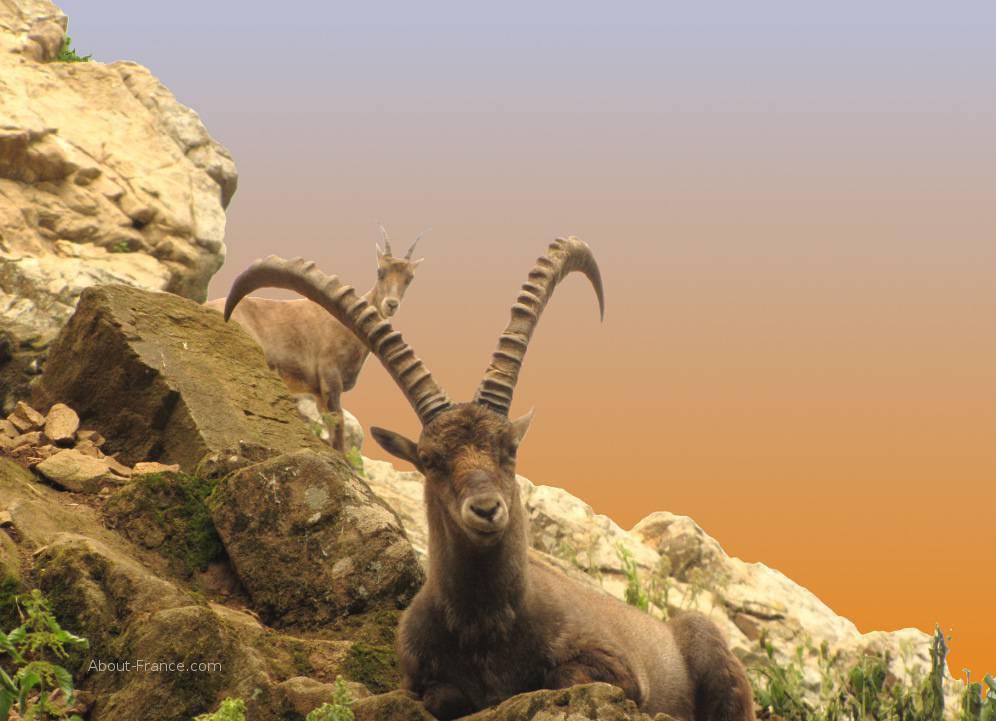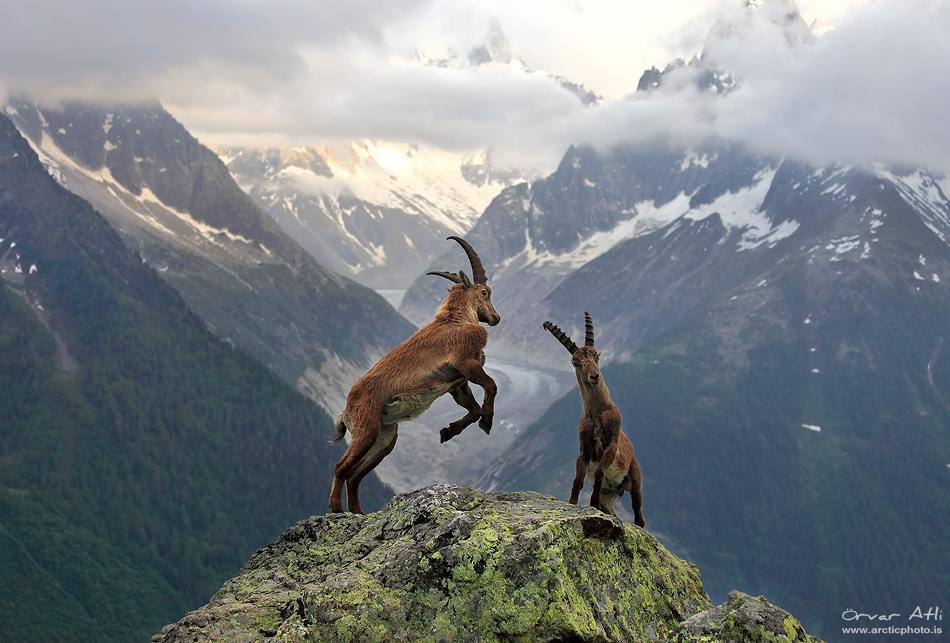The first image is the image on the left, the second image is the image on the right. Examine the images to the left and right. Is the description "The left and right image contains a total of two pairs of fight goat." accurate? Answer yes or no. No. 